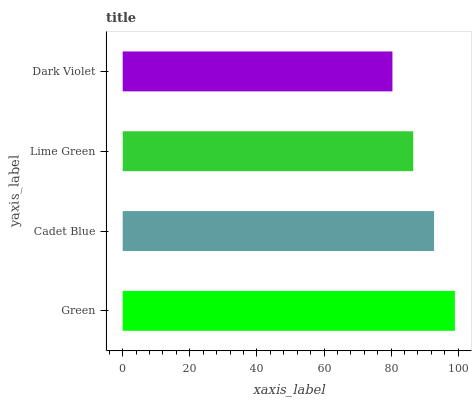Is Dark Violet the minimum?
Answer yes or no. Yes. Is Green the maximum?
Answer yes or no. Yes. Is Cadet Blue the minimum?
Answer yes or no. No. Is Cadet Blue the maximum?
Answer yes or no. No. Is Green greater than Cadet Blue?
Answer yes or no. Yes. Is Cadet Blue less than Green?
Answer yes or no. Yes. Is Cadet Blue greater than Green?
Answer yes or no. No. Is Green less than Cadet Blue?
Answer yes or no. No. Is Cadet Blue the high median?
Answer yes or no. Yes. Is Lime Green the low median?
Answer yes or no. Yes. Is Green the high median?
Answer yes or no. No. Is Dark Violet the low median?
Answer yes or no. No. 